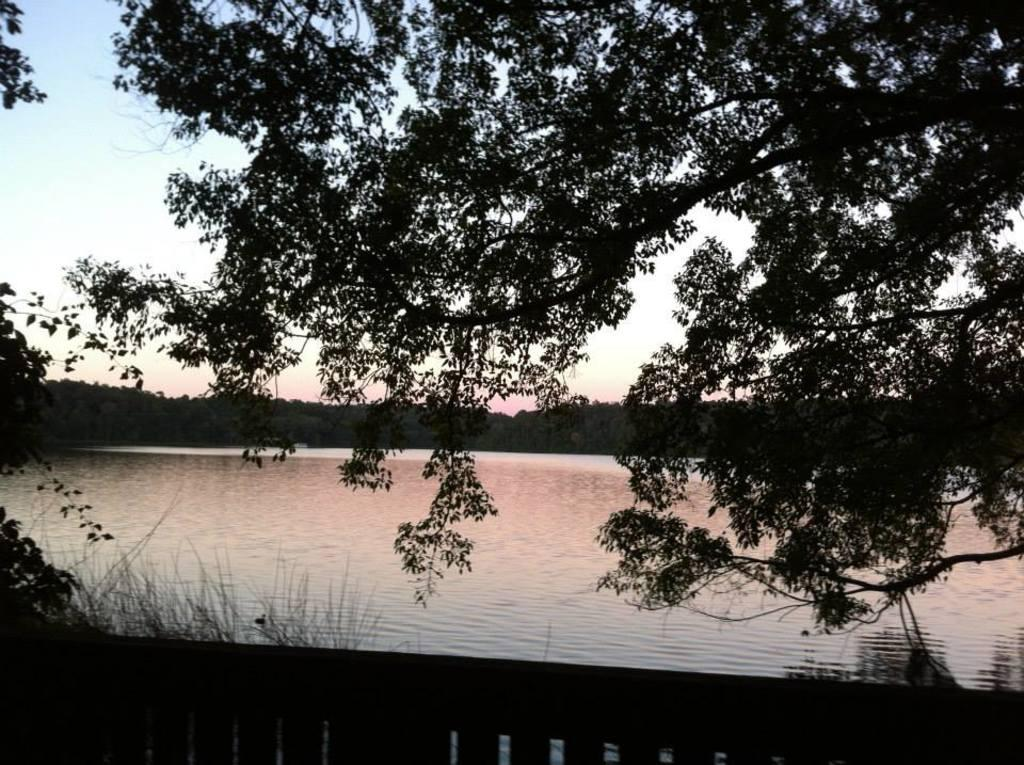What type of vegetation is present in the image? There are trees in the image. What type of ground cover is present in the image? There is grass in the image. What type of barrier is present in the image? There is fencing in the image. What type of water body is present in the image? There is a river in the image. What part of the natural environment is visible in the image? The sky is visible in the image. What type of rice is being cooked in the image? There is no rice present in the image. What type of drink is being served in the image? There is no drink present in the image. 